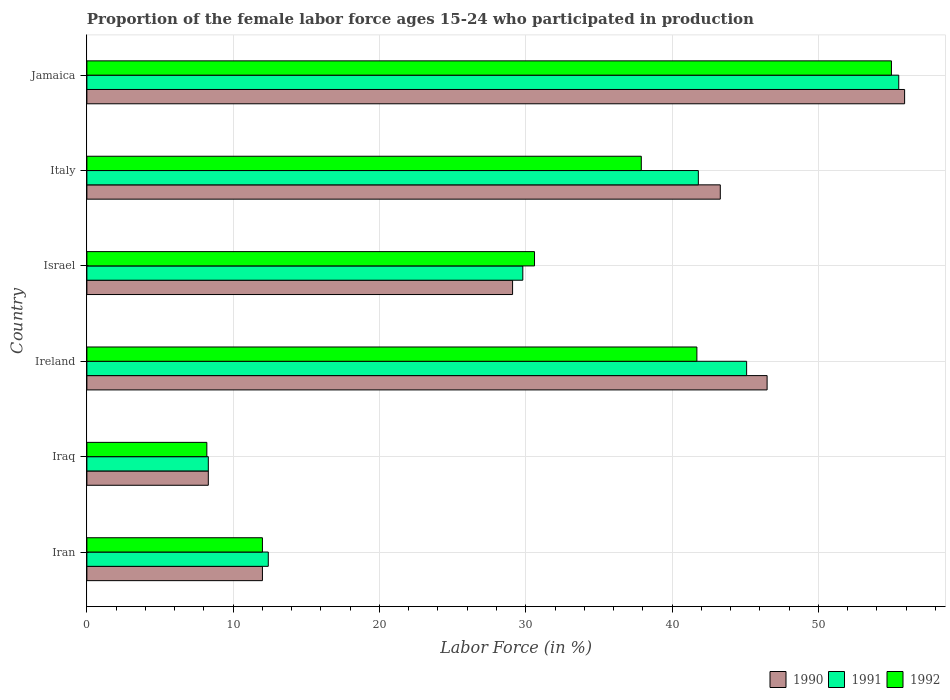Are the number of bars on each tick of the Y-axis equal?
Provide a succinct answer. Yes. How many bars are there on the 3rd tick from the top?
Provide a short and direct response. 3. How many bars are there on the 6th tick from the bottom?
Offer a very short reply. 3. What is the label of the 5th group of bars from the top?
Offer a terse response. Iraq. What is the proportion of the female labor force who participated in production in 1991 in Jamaica?
Give a very brief answer. 55.5. Across all countries, what is the maximum proportion of the female labor force who participated in production in 1991?
Offer a very short reply. 55.5. Across all countries, what is the minimum proportion of the female labor force who participated in production in 1991?
Your response must be concise. 8.3. In which country was the proportion of the female labor force who participated in production in 1990 maximum?
Provide a short and direct response. Jamaica. In which country was the proportion of the female labor force who participated in production in 1992 minimum?
Provide a succinct answer. Iraq. What is the total proportion of the female labor force who participated in production in 1992 in the graph?
Offer a very short reply. 185.4. What is the difference between the proportion of the female labor force who participated in production in 1992 in Iraq and that in Jamaica?
Make the answer very short. -46.8. What is the difference between the proportion of the female labor force who participated in production in 1990 in Israel and the proportion of the female labor force who participated in production in 1991 in Ireland?
Your response must be concise. -16. What is the average proportion of the female labor force who participated in production in 1990 per country?
Ensure brevity in your answer.  32.52. What is the difference between the proportion of the female labor force who participated in production in 1990 and proportion of the female labor force who participated in production in 1991 in Jamaica?
Keep it short and to the point. 0.4. In how many countries, is the proportion of the female labor force who participated in production in 1992 greater than 26 %?
Provide a short and direct response. 4. What is the ratio of the proportion of the female labor force who participated in production in 1990 in Ireland to that in Italy?
Keep it short and to the point. 1.07. Is the difference between the proportion of the female labor force who participated in production in 1990 in Iran and Iraq greater than the difference between the proportion of the female labor force who participated in production in 1991 in Iran and Iraq?
Provide a succinct answer. No. What is the difference between the highest and the second highest proportion of the female labor force who participated in production in 1991?
Provide a short and direct response. 10.4. What is the difference between the highest and the lowest proportion of the female labor force who participated in production in 1990?
Offer a very short reply. 47.6. Is the sum of the proportion of the female labor force who participated in production in 1990 in Iraq and Jamaica greater than the maximum proportion of the female labor force who participated in production in 1991 across all countries?
Make the answer very short. Yes. What does the 2nd bar from the top in Ireland represents?
Provide a short and direct response. 1991. What does the 1st bar from the bottom in Iraq represents?
Ensure brevity in your answer.  1990. Is it the case that in every country, the sum of the proportion of the female labor force who participated in production in 1991 and proportion of the female labor force who participated in production in 1992 is greater than the proportion of the female labor force who participated in production in 1990?
Provide a short and direct response. Yes. What is the difference between two consecutive major ticks on the X-axis?
Keep it short and to the point. 10. Does the graph contain any zero values?
Offer a terse response. No. Does the graph contain grids?
Your answer should be compact. Yes. Where does the legend appear in the graph?
Offer a very short reply. Bottom right. How many legend labels are there?
Keep it short and to the point. 3. What is the title of the graph?
Give a very brief answer. Proportion of the female labor force ages 15-24 who participated in production. Does "1992" appear as one of the legend labels in the graph?
Your answer should be very brief. Yes. What is the label or title of the X-axis?
Provide a succinct answer. Labor Force (in %). What is the label or title of the Y-axis?
Provide a succinct answer. Country. What is the Labor Force (in %) of 1990 in Iran?
Your response must be concise. 12. What is the Labor Force (in %) of 1991 in Iran?
Provide a succinct answer. 12.4. What is the Labor Force (in %) in 1990 in Iraq?
Your answer should be compact. 8.3. What is the Labor Force (in %) of 1991 in Iraq?
Keep it short and to the point. 8.3. What is the Labor Force (in %) of 1992 in Iraq?
Give a very brief answer. 8.2. What is the Labor Force (in %) in 1990 in Ireland?
Your answer should be compact. 46.5. What is the Labor Force (in %) of 1991 in Ireland?
Your response must be concise. 45.1. What is the Labor Force (in %) in 1992 in Ireland?
Give a very brief answer. 41.7. What is the Labor Force (in %) in 1990 in Israel?
Provide a short and direct response. 29.1. What is the Labor Force (in %) of 1991 in Israel?
Provide a short and direct response. 29.8. What is the Labor Force (in %) of 1992 in Israel?
Your answer should be very brief. 30.6. What is the Labor Force (in %) in 1990 in Italy?
Your answer should be compact. 43.3. What is the Labor Force (in %) in 1991 in Italy?
Your answer should be very brief. 41.8. What is the Labor Force (in %) of 1992 in Italy?
Keep it short and to the point. 37.9. What is the Labor Force (in %) of 1990 in Jamaica?
Keep it short and to the point. 55.9. What is the Labor Force (in %) of 1991 in Jamaica?
Your answer should be very brief. 55.5. What is the Labor Force (in %) in 1992 in Jamaica?
Make the answer very short. 55. Across all countries, what is the maximum Labor Force (in %) in 1990?
Make the answer very short. 55.9. Across all countries, what is the maximum Labor Force (in %) in 1991?
Your response must be concise. 55.5. Across all countries, what is the minimum Labor Force (in %) of 1990?
Your answer should be very brief. 8.3. Across all countries, what is the minimum Labor Force (in %) in 1991?
Offer a terse response. 8.3. Across all countries, what is the minimum Labor Force (in %) of 1992?
Give a very brief answer. 8.2. What is the total Labor Force (in %) in 1990 in the graph?
Your answer should be very brief. 195.1. What is the total Labor Force (in %) in 1991 in the graph?
Make the answer very short. 192.9. What is the total Labor Force (in %) of 1992 in the graph?
Your response must be concise. 185.4. What is the difference between the Labor Force (in %) in 1990 in Iran and that in Iraq?
Provide a succinct answer. 3.7. What is the difference between the Labor Force (in %) in 1991 in Iran and that in Iraq?
Your response must be concise. 4.1. What is the difference between the Labor Force (in %) of 1992 in Iran and that in Iraq?
Your response must be concise. 3.8. What is the difference between the Labor Force (in %) of 1990 in Iran and that in Ireland?
Ensure brevity in your answer.  -34.5. What is the difference between the Labor Force (in %) of 1991 in Iran and that in Ireland?
Offer a very short reply. -32.7. What is the difference between the Labor Force (in %) of 1992 in Iran and that in Ireland?
Give a very brief answer. -29.7. What is the difference between the Labor Force (in %) in 1990 in Iran and that in Israel?
Make the answer very short. -17.1. What is the difference between the Labor Force (in %) of 1991 in Iran and that in Israel?
Offer a terse response. -17.4. What is the difference between the Labor Force (in %) in 1992 in Iran and that in Israel?
Offer a terse response. -18.6. What is the difference between the Labor Force (in %) in 1990 in Iran and that in Italy?
Your response must be concise. -31.3. What is the difference between the Labor Force (in %) of 1991 in Iran and that in Italy?
Make the answer very short. -29.4. What is the difference between the Labor Force (in %) in 1992 in Iran and that in Italy?
Give a very brief answer. -25.9. What is the difference between the Labor Force (in %) in 1990 in Iran and that in Jamaica?
Your answer should be very brief. -43.9. What is the difference between the Labor Force (in %) in 1991 in Iran and that in Jamaica?
Provide a short and direct response. -43.1. What is the difference between the Labor Force (in %) of 1992 in Iran and that in Jamaica?
Offer a terse response. -43. What is the difference between the Labor Force (in %) of 1990 in Iraq and that in Ireland?
Give a very brief answer. -38.2. What is the difference between the Labor Force (in %) in 1991 in Iraq and that in Ireland?
Make the answer very short. -36.8. What is the difference between the Labor Force (in %) in 1992 in Iraq and that in Ireland?
Offer a terse response. -33.5. What is the difference between the Labor Force (in %) in 1990 in Iraq and that in Israel?
Make the answer very short. -20.8. What is the difference between the Labor Force (in %) in 1991 in Iraq and that in Israel?
Offer a very short reply. -21.5. What is the difference between the Labor Force (in %) of 1992 in Iraq and that in Israel?
Your answer should be very brief. -22.4. What is the difference between the Labor Force (in %) in 1990 in Iraq and that in Italy?
Ensure brevity in your answer.  -35. What is the difference between the Labor Force (in %) in 1991 in Iraq and that in Italy?
Provide a succinct answer. -33.5. What is the difference between the Labor Force (in %) in 1992 in Iraq and that in Italy?
Offer a very short reply. -29.7. What is the difference between the Labor Force (in %) of 1990 in Iraq and that in Jamaica?
Ensure brevity in your answer.  -47.6. What is the difference between the Labor Force (in %) of 1991 in Iraq and that in Jamaica?
Your answer should be compact. -47.2. What is the difference between the Labor Force (in %) in 1992 in Iraq and that in Jamaica?
Keep it short and to the point. -46.8. What is the difference between the Labor Force (in %) in 1990 in Ireland and that in Jamaica?
Provide a succinct answer. -9.4. What is the difference between the Labor Force (in %) of 1992 in Ireland and that in Jamaica?
Offer a very short reply. -13.3. What is the difference between the Labor Force (in %) in 1990 in Israel and that in Italy?
Make the answer very short. -14.2. What is the difference between the Labor Force (in %) of 1991 in Israel and that in Italy?
Your answer should be very brief. -12. What is the difference between the Labor Force (in %) in 1990 in Israel and that in Jamaica?
Your answer should be very brief. -26.8. What is the difference between the Labor Force (in %) in 1991 in Israel and that in Jamaica?
Your response must be concise. -25.7. What is the difference between the Labor Force (in %) of 1992 in Israel and that in Jamaica?
Your answer should be compact. -24.4. What is the difference between the Labor Force (in %) of 1991 in Italy and that in Jamaica?
Offer a very short reply. -13.7. What is the difference between the Labor Force (in %) of 1992 in Italy and that in Jamaica?
Give a very brief answer. -17.1. What is the difference between the Labor Force (in %) of 1990 in Iran and the Labor Force (in %) of 1992 in Iraq?
Your response must be concise. 3.8. What is the difference between the Labor Force (in %) in 1990 in Iran and the Labor Force (in %) in 1991 in Ireland?
Give a very brief answer. -33.1. What is the difference between the Labor Force (in %) in 1990 in Iran and the Labor Force (in %) in 1992 in Ireland?
Your answer should be compact. -29.7. What is the difference between the Labor Force (in %) of 1991 in Iran and the Labor Force (in %) of 1992 in Ireland?
Provide a short and direct response. -29.3. What is the difference between the Labor Force (in %) of 1990 in Iran and the Labor Force (in %) of 1991 in Israel?
Ensure brevity in your answer.  -17.8. What is the difference between the Labor Force (in %) of 1990 in Iran and the Labor Force (in %) of 1992 in Israel?
Give a very brief answer. -18.6. What is the difference between the Labor Force (in %) of 1991 in Iran and the Labor Force (in %) of 1992 in Israel?
Provide a short and direct response. -18.2. What is the difference between the Labor Force (in %) of 1990 in Iran and the Labor Force (in %) of 1991 in Italy?
Provide a succinct answer. -29.8. What is the difference between the Labor Force (in %) in 1990 in Iran and the Labor Force (in %) in 1992 in Italy?
Your response must be concise. -25.9. What is the difference between the Labor Force (in %) of 1991 in Iran and the Labor Force (in %) of 1992 in Italy?
Make the answer very short. -25.5. What is the difference between the Labor Force (in %) of 1990 in Iran and the Labor Force (in %) of 1991 in Jamaica?
Offer a very short reply. -43.5. What is the difference between the Labor Force (in %) in 1990 in Iran and the Labor Force (in %) in 1992 in Jamaica?
Give a very brief answer. -43. What is the difference between the Labor Force (in %) in 1991 in Iran and the Labor Force (in %) in 1992 in Jamaica?
Provide a short and direct response. -42.6. What is the difference between the Labor Force (in %) of 1990 in Iraq and the Labor Force (in %) of 1991 in Ireland?
Your answer should be compact. -36.8. What is the difference between the Labor Force (in %) of 1990 in Iraq and the Labor Force (in %) of 1992 in Ireland?
Ensure brevity in your answer.  -33.4. What is the difference between the Labor Force (in %) of 1991 in Iraq and the Labor Force (in %) of 1992 in Ireland?
Ensure brevity in your answer.  -33.4. What is the difference between the Labor Force (in %) of 1990 in Iraq and the Labor Force (in %) of 1991 in Israel?
Offer a terse response. -21.5. What is the difference between the Labor Force (in %) in 1990 in Iraq and the Labor Force (in %) in 1992 in Israel?
Your answer should be compact. -22.3. What is the difference between the Labor Force (in %) in 1991 in Iraq and the Labor Force (in %) in 1992 in Israel?
Offer a very short reply. -22.3. What is the difference between the Labor Force (in %) in 1990 in Iraq and the Labor Force (in %) in 1991 in Italy?
Make the answer very short. -33.5. What is the difference between the Labor Force (in %) in 1990 in Iraq and the Labor Force (in %) in 1992 in Italy?
Ensure brevity in your answer.  -29.6. What is the difference between the Labor Force (in %) in 1991 in Iraq and the Labor Force (in %) in 1992 in Italy?
Give a very brief answer. -29.6. What is the difference between the Labor Force (in %) in 1990 in Iraq and the Labor Force (in %) in 1991 in Jamaica?
Keep it short and to the point. -47.2. What is the difference between the Labor Force (in %) in 1990 in Iraq and the Labor Force (in %) in 1992 in Jamaica?
Your response must be concise. -46.7. What is the difference between the Labor Force (in %) in 1991 in Iraq and the Labor Force (in %) in 1992 in Jamaica?
Ensure brevity in your answer.  -46.7. What is the difference between the Labor Force (in %) in 1990 in Ireland and the Labor Force (in %) in 1991 in Israel?
Your answer should be very brief. 16.7. What is the difference between the Labor Force (in %) of 1990 in Ireland and the Labor Force (in %) of 1992 in Israel?
Give a very brief answer. 15.9. What is the difference between the Labor Force (in %) of 1991 in Ireland and the Labor Force (in %) of 1992 in Israel?
Offer a terse response. 14.5. What is the difference between the Labor Force (in %) in 1990 in Ireland and the Labor Force (in %) in 1991 in Italy?
Your answer should be very brief. 4.7. What is the difference between the Labor Force (in %) of 1990 in Ireland and the Labor Force (in %) of 1992 in Italy?
Offer a very short reply. 8.6. What is the difference between the Labor Force (in %) of 1990 in Ireland and the Labor Force (in %) of 1991 in Jamaica?
Ensure brevity in your answer.  -9. What is the difference between the Labor Force (in %) of 1991 in Israel and the Labor Force (in %) of 1992 in Italy?
Offer a very short reply. -8.1. What is the difference between the Labor Force (in %) in 1990 in Israel and the Labor Force (in %) in 1991 in Jamaica?
Your answer should be compact. -26.4. What is the difference between the Labor Force (in %) in 1990 in Israel and the Labor Force (in %) in 1992 in Jamaica?
Give a very brief answer. -25.9. What is the difference between the Labor Force (in %) of 1991 in Israel and the Labor Force (in %) of 1992 in Jamaica?
Make the answer very short. -25.2. What is the difference between the Labor Force (in %) of 1990 in Italy and the Labor Force (in %) of 1992 in Jamaica?
Your answer should be compact. -11.7. What is the average Labor Force (in %) in 1990 per country?
Give a very brief answer. 32.52. What is the average Labor Force (in %) in 1991 per country?
Offer a terse response. 32.15. What is the average Labor Force (in %) of 1992 per country?
Provide a short and direct response. 30.9. What is the difference between the Labor Force (in %) in 1990 and Labor Force (in %) in 1991 in Iran?
Your response must be concise. -0.4. What is the difference between the Labor Force (in %) in 1990 and Labor Force (in %) in 1992 in Iran?
Your response must be concise. 0. What is the difference between the Labor Force (in %) of 1990 and Labor Force (in %) of 1991 in Iraq?
Make the answer very short. 0. What is the difference between the Labor Force (in %) of 1991 and Labor Force (in %) of 1992 in Iraq?
Offer a terse response. 0.1. What is the difference between the Labor Force (in %) of 1990 and Labor Force (in %) of 1991 in Ireland?
Provide a short and direct response. 1.4. What is the difference between the Labor Force (in %) of 1990 and Labor Force (in %) of 1992 in Ireland?
Your answer should be compact. 4.8. What is the difference between the Labor Force (in %) of 1991 and Labor Force (in %) of 1992 in Ireland?
Your answer should be compact. 3.4. What is the difference between the Labor Force (in %) of 1990 and Labor Force (in %) of 1991 in Israel?
Offer a terse response. -0.7. What is the difference between the Labor Force (in %) in 1990 and Labor Force (in %) in 1992 in Israel?
Keep it short and to the point. -1.5. What is the difference between the Labor Force (in %) in 1991 and Labor Force (in %) in 1992 in Italy?
Offer a very short reply. 3.9. What is the difference between the Labor Force (in %) in 1990 and Labor Force (in %) in 1991 in Jamaica?
Offer a very short reply. 0.4. What is the difference between the Labor Force (in %) in 1990 and Labor Force (in %) in 1992 in Jamaica?
Your answer should be very brief. 0.9. What is the ratio of the Labor Force (in %) in 1990 in Iran to that in Iraq?
Give a very brief answer. 1.45. What is the ratio of the Labor Force (in %) in 1991 in Iran to that in Iraq?
Your response must be concise. 1.49. What is the ratio of the Labor Force (in %) in 1992 in Iran to that in Iraq?
Make the answer very short. 1.46. What is the ratio of the Labor Force (in %) in 1990 in Iran to that in Ireland?
Keep it short and to the point. 0.26. What is the ratio of the Labor Force (in %) of 1991 in Iran to that in Ireland?
Offer a terse response. 0.27. What is the ratio of the Labor Force (in %) in 1992 in Iran to that in Ireland?
Keep it short and to the point. 0.29. What is the ratio of the Labor Force (in %) in 1990 in Iran to that in Israel?
Make the answer very short. 0.41. What is the ratio of the Labor Force (in %) of 1991 in Iran to that in Israel?
Provide a succinct answer. 0.42. What is the ratio of the Labor Force (in %) in 1992 in Iran to that in Israel?
Offer a terse response. 0.39. What is the ratio of the Labor Force (in %) in 1990 in Iran to that in Italy?
Offer a very short reply. 0.28. What is the ratio of the Labor Force (in %) of 1991 in Iran to that in Italy?
Your answer should be very brief. 0.3. What is the ratio of the Labor Force (in %) of 1992 in Iran to that in Italy?
Give a very brief answer. 0.32. What is the ratio of the Labor Force (in %) of 1990 in Iran to that in Jamaica?
Your response must be concise. 0.21. What is the ratio of the Labor Force (in %) of 1991 in Iran to that in Jamaica?
Your answer should be compact. 0.22. What is the ratio of the Labor Force (in %) of 1992 in Iran to that in Jamaica?
Your answer should be very brief. 0.22. What is the ratio of the Labor Force (in %) in 1990 in Iraq to that in Ireland?
Give a very brief answer. 0.18. What is the ratio of the Labor Force (in %) in 1991 in Iraq to that in Ireland?
Give a very brief answer. 0.18. What is the ratio of the Labor Force (in %) in 1992 in Iraq to that in Ireland?
Make the answer very short. 0.2. What is the ratio of the Labor Force (in %) in 1990 in Iraq to that in Israel?
Keep it short and to the point. 0.29. What is the ratio of the Labor Force (in %) of 1991 in Iraq to that in Israel?
Give a very brief answer. 0.28. What is the ratio of the Labor Force (in %) in 1992 in Iraq to that in Israel?
Make the answer very short. 0.27. What is the ratio of the Labor Force (in %) of 1990 in Iraq to that in Italy?
Provide a short and direct response. 0.19. What is the ratio of the Labor Force (in %) of 1991 in Iraq to that in Italy?
Provide a short and direct response. 0.2. What is the ratio of the Labor Force (in %) in 1992 in Iraq to that in Italy?
Provide a short and direct response. 0.22. What is the ratio of the Labor Force (in %) of 1990 in Iraq to that in Jamaica?
Your response must be concise. 0.15. What is the ratio of the Labor Force (in %) in 1991 in Iraq to that in Jamaica?
Your answer should be very brief. 0.15. What is the ratio of the Labor Force (in %) of 1992 in Iraq to that in Jamaica?
Your answer should be compact. 0.15. What is the ratio of the Labor Force (in %) of 1990 in Ireland to that in Israel?
Offer a very short reply. 1.6. What is the ratio of the Labor Force (in %) of 1991 in Ireland to that in Israel?
Provide a succinct answer. 1.51. What is the ratio of the Labor Force (in %) in 1992 in Ireland to that in Israel?
Keep it short and to the point. 1.36. What is the ratio of the Labor Force (in %) of 1990 in Ireland to that in Italy?
Keep it short and to the point. 1.07. What is the ratio of the Labor Force (in %) of 1991 in Ireland to that in Italy?
Provide a short and direct response. 1.08. What is the ratio of the Labor Force (in %) in 1992 in Ireland to that in Italy?
Your answer should be compact. 1.1. What is the ratio of the Labor Force (in %) of 1990 in Ireland to that in Jamaica?
Provide a short and direct response. 0.83. What is the ratio of the Labor Force (in %) in 1991 in Ireland to that in Jamaica?
Your response must be concise. 0.81. What is the ratio of the Labor Force (in %) in 1992 in Ireland to that in Jamaica?
Make the answer very short. 0.76. What is the ratio of the Labor Force (in %) in 1990 in Israel to that in Italy?
Your response must be concise. 0.67. What is the ratio of the Labor Force (in %) of 1991 in Israel to that in Italy?
Provide a succinct answer. 0.71. What is the ratio of the Labor Force (in %) of 1992 in Israel to that in Italy?
Ensure brevity in your answer.  0.81. What is the ratio of the Labor Force (in %) in 1990 in Israel to that in Jamaica?
Keep it short and to the point. 0.52. What is the ratio of the Labor Force (in %) in 1991 in Israel to that in Jamaica?
Offer a terse response. 0.54. What is the ratio of the Labor Force (in %) of 1992 in Israel to that in Jamaica?
Your answer should be very brief. 0.56. What is the ratio of the Labor Force (in %) of 1990 in Italy to that in Jamaica?
Give a very brief answer. 0.77. What is the ratio of the Labor Force (in %) of 1991 in Italy to that in Jamaica?
Provide a succinct answer. 0.75. What is the ratio of the Labor Force (in %) of 1992 in Italy to that in Jamaica?
Your response must be concise. 0.69. What is the difference between the highest and the second highest Labor Force (in %) in 1990?
Your answer should be compact. 9.4. What is the difference between the highest and the second highest Labor Force (in %) of 1991?
Your response must be concise. 10.4. What is the difference between the highest and the second highest Labor Force (in %) in 1992?
Offer a very short reply. 13.3. What is the difference between the highest and the lowest Labor Force (in %) in 1990?
Offer a very short reply. 47.6. What is the difference between the highest and the lowest Labor Force (in %) in 1991?
Your answer should be compact. 47.2. What is the difference between the highest and the lowest Labor Force (in %) in 1992?
Provide a short and direct response. 46.8. 